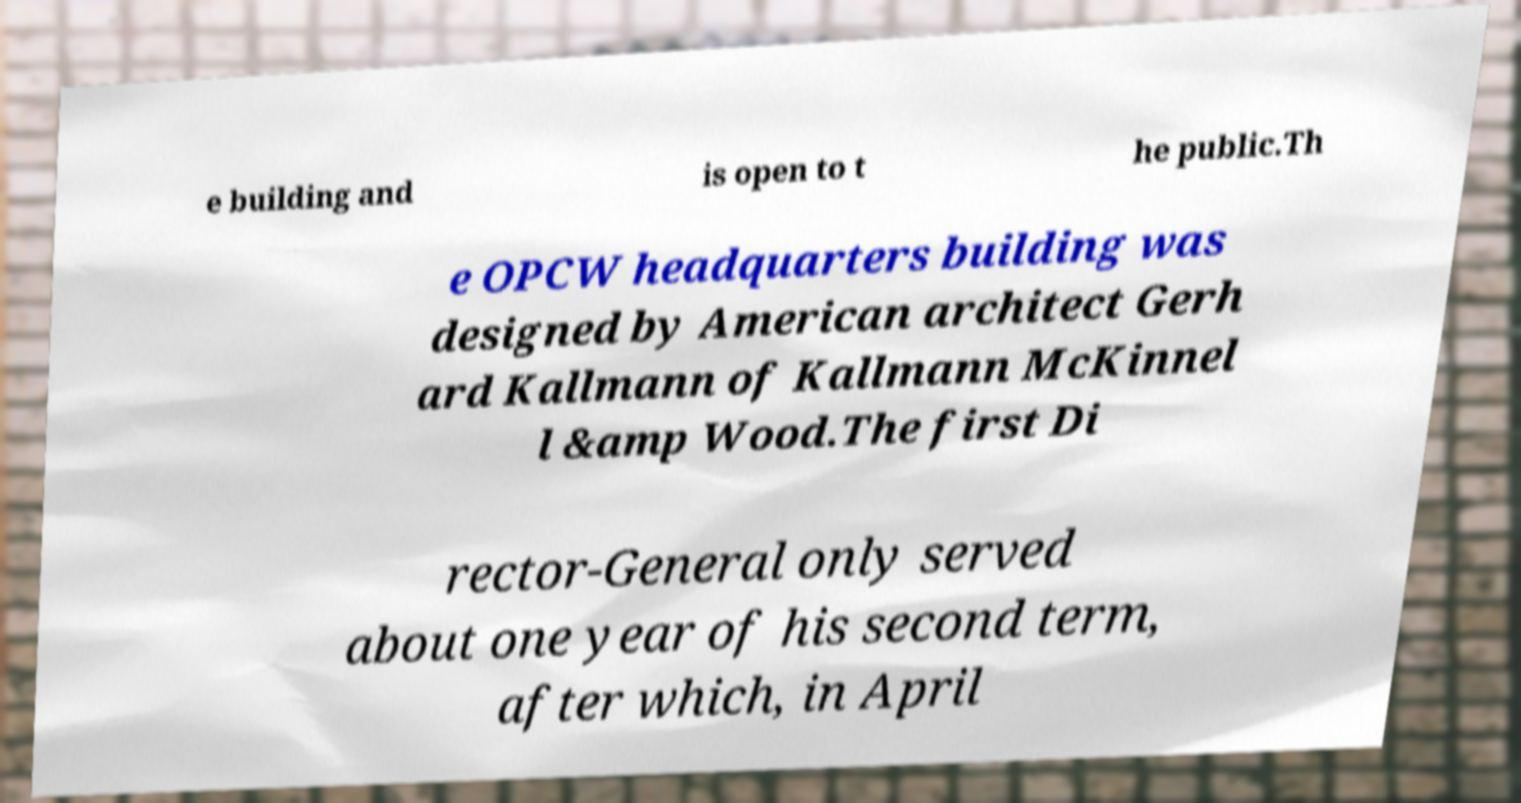Could you assist in decoding the text presented in this image and type it out clearly? e building and is open to t he public.Th e OPCW headquarters building was designed by American architect Gerh ard Kallmann of Kallmann McKinnel l &amp Wood.The first Di rector-General only served about one year of his second term, after which, in April 